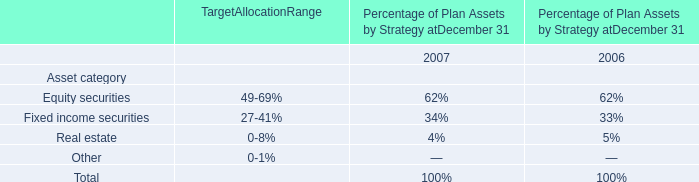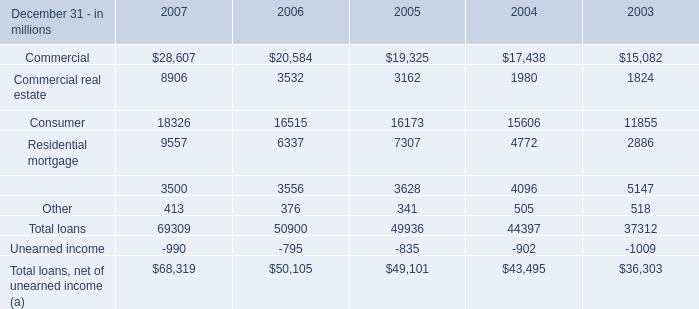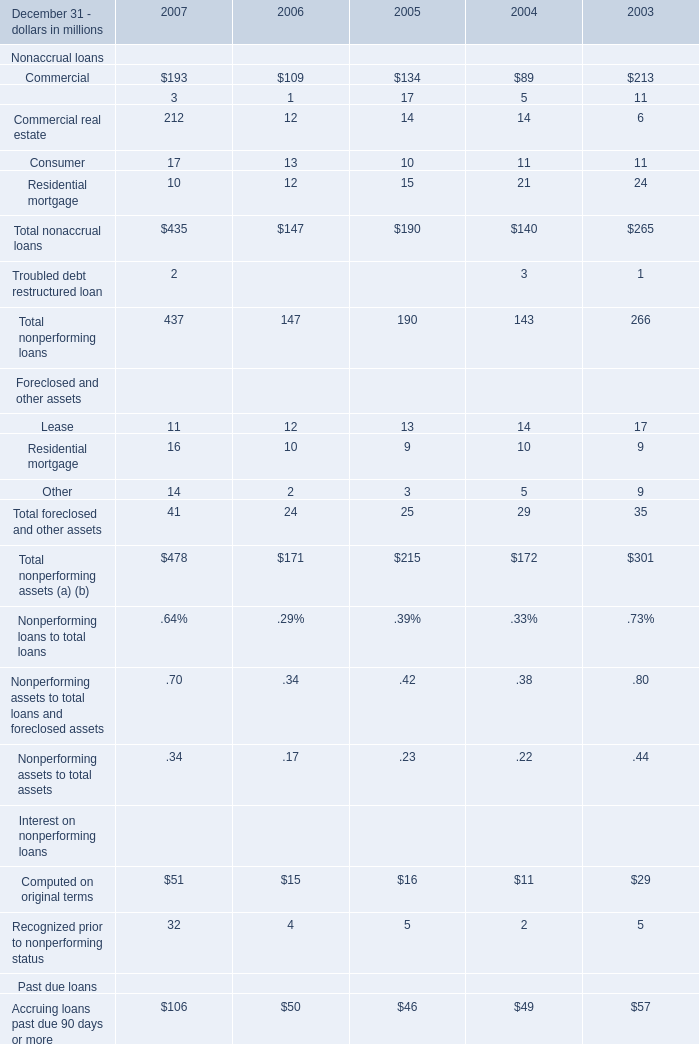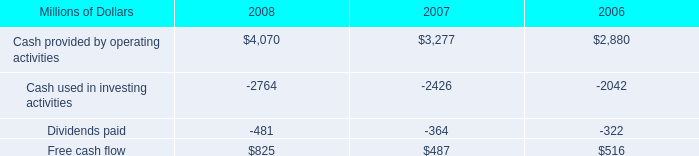what was the percentage change in free cash flow from 2006 to 2007? 
Computations: ((487 - 516) / 516)
Answer: -0.0562. 